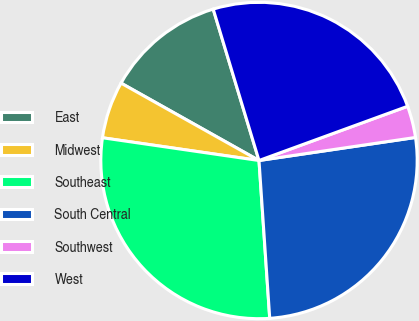Convert chart. <chart><loc_0><loc_0><loc_500><loc_500><pie_chart><fcel>East<fcel>Midwest<fcel>Southeast<fcel>South Central<fcel>Southwest<fcel>West<nl><fcel>12.19%<fcel>5.84%<fcel>28.38%<fcel>26.25%<fcel>3.24%<fcel>24.11%<nl></chart> 